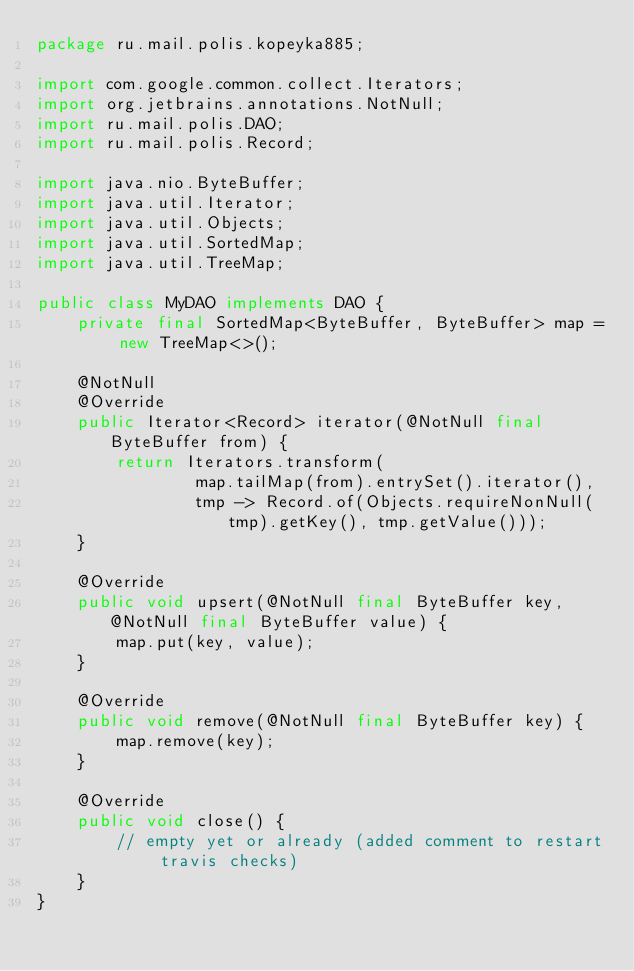Convert code to text. <code><loc_0><loc_0><loc_500><loc_500><_Java_>package ru.mail.polis.kopeyka885;

import com.google.common.collect.Iterators;
import org.jetbrains.annotations.NotNull;
import ru.mail.polis.DAO;
import ru.mail.polis.Record;

import java.nio.ByteBuffer;
import java.util.Iterator;
import java.util.Objects;
import java.util.SortedMap;
import java.util.TreeMap;

public class MyDAO implements DAO {
    private final SortedMap<ByteBuffer, ByteBuffer> map = new TreeMap<>();

    @NotNull
    @Override
    public Iterator<Record> iterator(@NotNull final ByteBuffer from) {
        return Iterators.transform(
                map.tailMap(from).entrySet().iterator(),
                tmp -> Record.of(Objects.requireNonNull(tmp).getKey(), tmp.getValue()));
    }

    @Override
    public void upsert(@NotNull final ByteBuffer key, @NotNull final ByteBuffer value) {
        map.put(key, value);
    }

    @Override
    public void remove(@NotNull final ByteBuffer key) {
        map.remove(key);
    }

    @Override
    public void close() {
        // empty yet or already (added comment to restart travis checks)
    }
}
</code> 